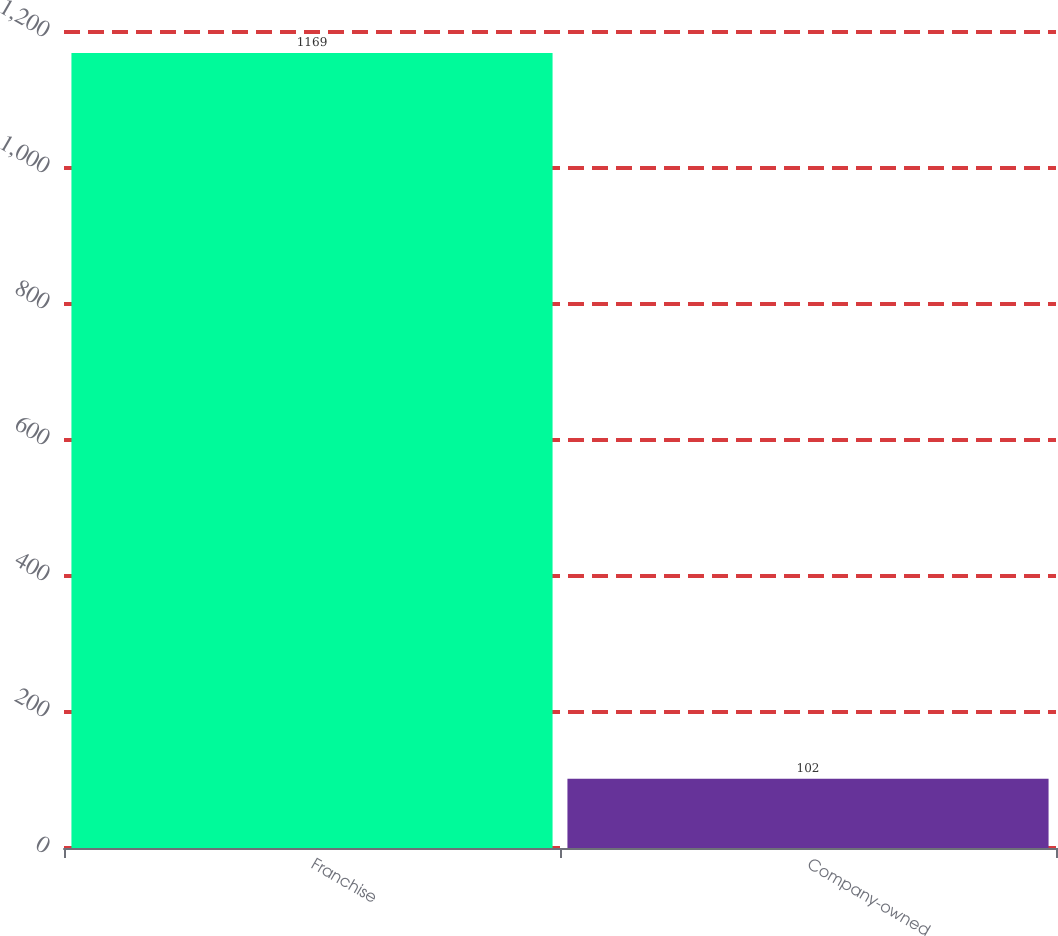Convert chart. <chart><loc_0><loc_0><loc_500><loc_500><bar_chart><fcel>Franchise<fcel>Company-owned<nl><fcel>1169<fcel>102<nl></chart> 